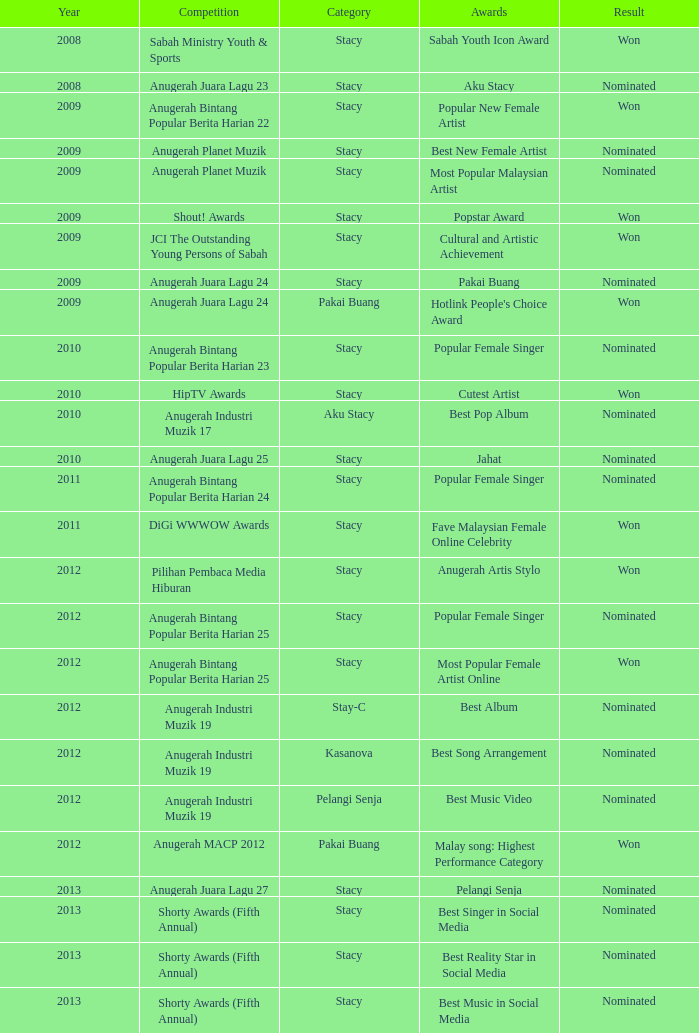What was the year that had Anugerah Bintang Popular Berita Harian 23 as competition? 1.0. 